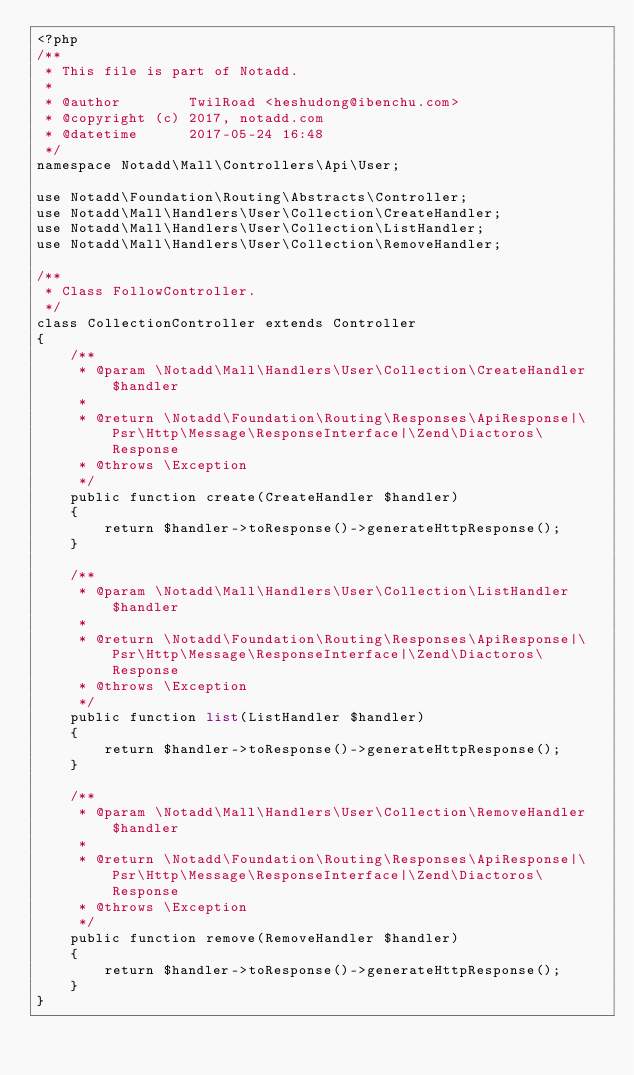Convert code to text. <code><loc_0><loc_0><loc_500><loc_500><_PHP_><?php
/**
 * This file is part of Notadd.
 *
 * @author        TwilRoad <heshudong@ibenchu.com>
 * @copyright (c) 2017, notadd.com
 * @datetime      2017-05-24 16:48
 */
namespace Notadd\Mall\Controllers\Api\User;

use Notadd\Foundation\Routing\Abstracts\Controller;
use Notadd\Mall\Handlers\User\Collection\CreateHandler;
use Notadd\Mall\Handlers\User\Collection\ListHandler;
use Notadd\Mall\Handlers\User\Collection\RemoveHandler;

/**
 * Class FollowController.
 */
class CollectionController extends Controller
{
    /**
     * @param \Notadd\Mall\Handlers\User\Collection\CreateHandler $handler
     *
     * @return \Notadd\Foundation\Routing\Responses\ApiResponse|\Psr\Http\Message\ResponseInterface|\Zend\Diactoros\Response
     * @throws \Exception
     */
    public function create(CreateHandler $handler)
    {
        return $handler->toResponse()->generateHttpResponse();
    }

    /**
     * @param \Notadd\Mall\Handlers\User\Collection\ListHandler $handler
     *
     * @return \Notadd\Foundation\Routing\Responses\ApiResponse|\Psr\Http\Message\ResponseInterface|\Zend\Diactoros\Response
     * @throws \Exception
     */
    public function list(ListHandler $handler)
    {
        return $handler->toResponse()->generateHttpResponse();
    }

    /**
     * @param \Notadd\Mall\Handlers\User\Collection\RemoveHandler $handler
     *
     * @return \Notadd\Foundation\Routing\Responses\ApiResponse|\Psr\Http\Message\ResponseInterface|\Zend\Diactoros\Response
     * @throws \Exception
     */
    public function remove(RemoveHandler $handler)
    {
        return $handler->toResponse()->generateHttpResponse();
    }
}
</code> 